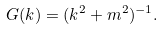<formula> <loc_0><loc_0><loc_500><loc_500>G ( k ) = ( k ^ { 2 } + m ^ { 2 } ) ^ { - 1 } .</formula> 